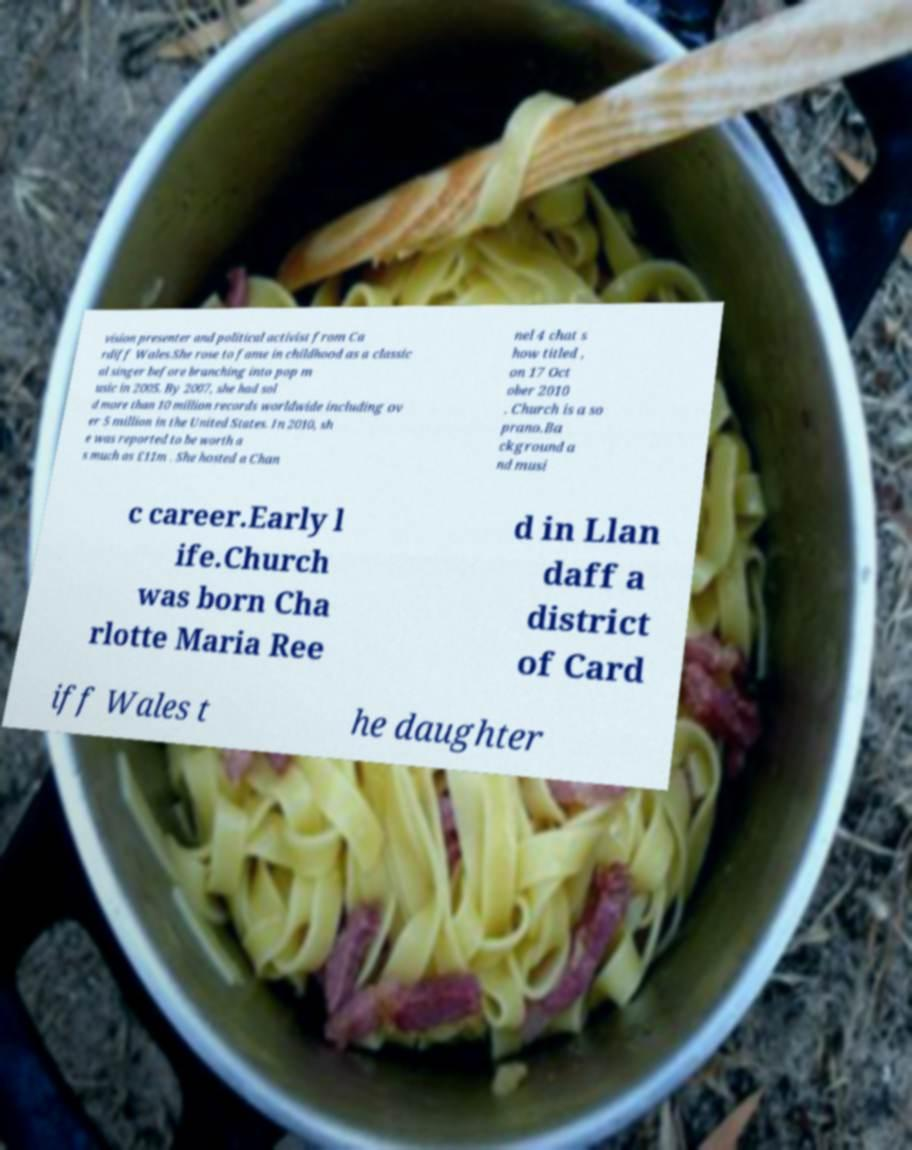Please read and relay the text visible in this image. What does it say? vision presenter and political activist from Ca rdiff Wales.She rose to fame in childhood as a classic al singer before branching into pop m usic in 2005. By 2007, she had sol d more than 10 million records worldwide including ov er 5 million in the United States. In 2010, sh e was reported to be worth a s much as £11m . She hosted a Chan nel 4 chat s how titled , on 17 Oct ober 2010 . Church is a so prano.Ba ckground a nd musi c career.Early l ife.Church was born Cha rlotte Maria Ree d in Llan daff a district of Card iff Wales t he daughter 